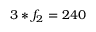Convert formula to latex. <formula><loc_0><loc_0><loc_500><loc_500>3 * f _ { 2 } = 2 4 0</formula> 